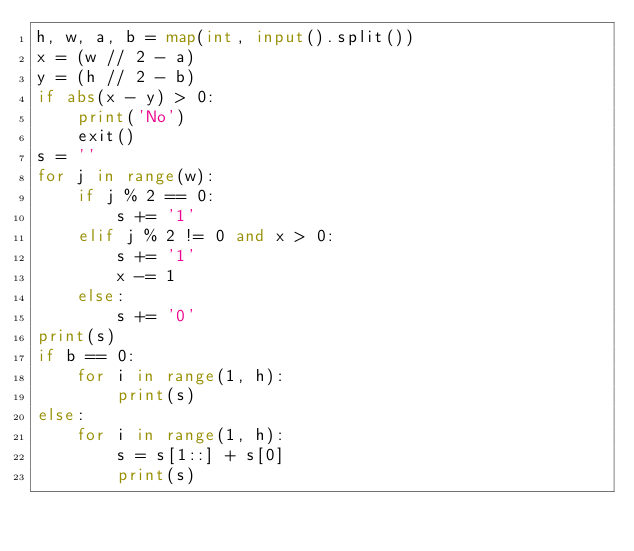<code> <loc_0><loc_0><loc_500><loc_500><_Python_>h, w, a, b = map(int, input().split())
x = (w // 2 - a)
y = (h // 2 - b)
if abs(x - y) > 0:
    print('No')
    exit()
s = ''
for j in range(w):
    if j % 2 == 0:
        s += '1'
    elif j % 2 != 0 and x > 0:
        s += '1'
        x -= 1
    else:
        s += '0'
print(s)
if b == 0:
    for i in range(1, h):
        print(s)
else:
    for i in range(1, h):
        s = s[1::] + s[0]
        print(s)
</code> 